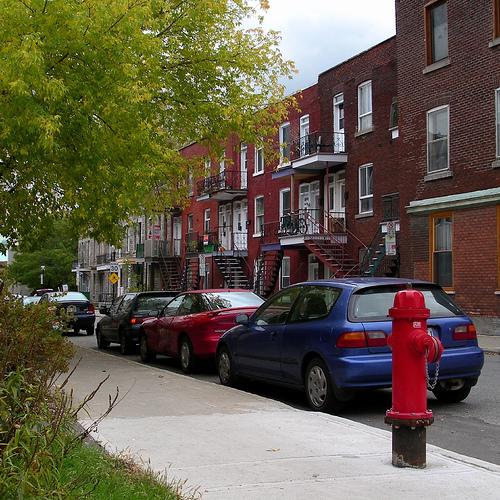How many cars are the same color as the fire hydrant?
Concise answer only. 1. How many cars are pictured?
Give a very brief answer. 4. Is this a construction site?
Write a very short answer. No. What is the red object?
Give a very brief answer. Fire hydrant. What is coming up on the left?
Short answer required. Tree. What is lining the street?
Write a very short answer. Cars. How tall is the fire hydrant?
Write a very short answer. 3 feet. Is there a fire hydrant in this photo?
Answer briefly. Yes. What brand is the smallest car?
Write a very short answer. Honda. What tint of pink is the fire hydrant?
Answer briefly. Red. What is the body style of the vehicle in the background of this picture?
Concise answer only. Hatchback. Are the tail lights of the red car on?
Short answer required. No. How many cars in the photo?
Keep it brief. 4. From where is the smoke coming?
Keep it brief. No smoke. Are there any palm trees by the sidewalk?
Keep it brief. No. What are the colors of the fire hydrant?
Quick response, please. Red and black. What color is the car?
Answer briefly. Blue. What is the model of the cars?
Quick response, please. Ford. 